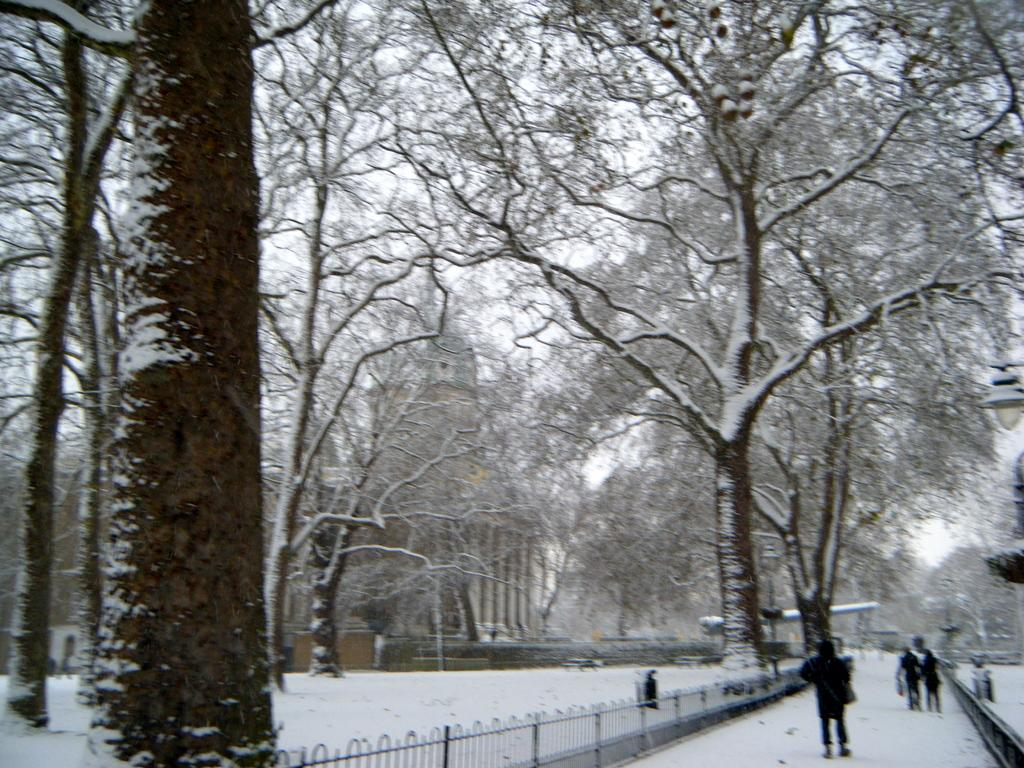What can be seen in the image? There is a group of people in the image. What are the people wearing? The people are wearing black color dresses. What architectural feature is visible in the image? There is railing visible in the image. What can be seen in the background of the image? There are many trees and a white sky in the background of the image. What type of bag is the police officer carrying in the image? There is no police officer or bag present in the image. Who is the father of the person standing next to the railing in the image? There is no information about a father or a person standing next to the railing in the image. 